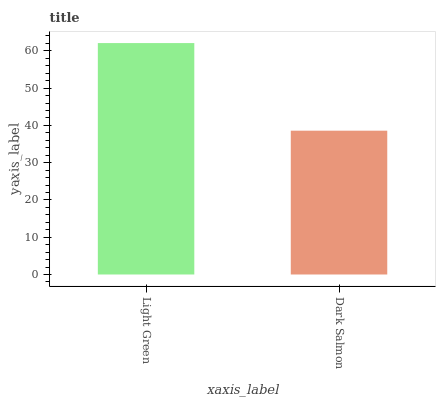Is Dark Salmon the maximum?
Answer yes or no. No. Is Light Green greater than Dark Salmon?
Answer yes or no. Yes. Is Dark Salmon less than Light Green?
Answer yes or no. Yes. Is Dark Salmon greater than Light Green?
Answer yes or no. No. Is Light Green less than Dark Salmon?
Answer yes or no. No. Is Light Green the high median?
Answer yes or no. Yes. Is Dark Salmon the low median?
Answer yes or no. Yes. Is Dark Salmon the high median?
Answer yes or no. No. Is Light Green the low median?
Answer yes or no. No. 